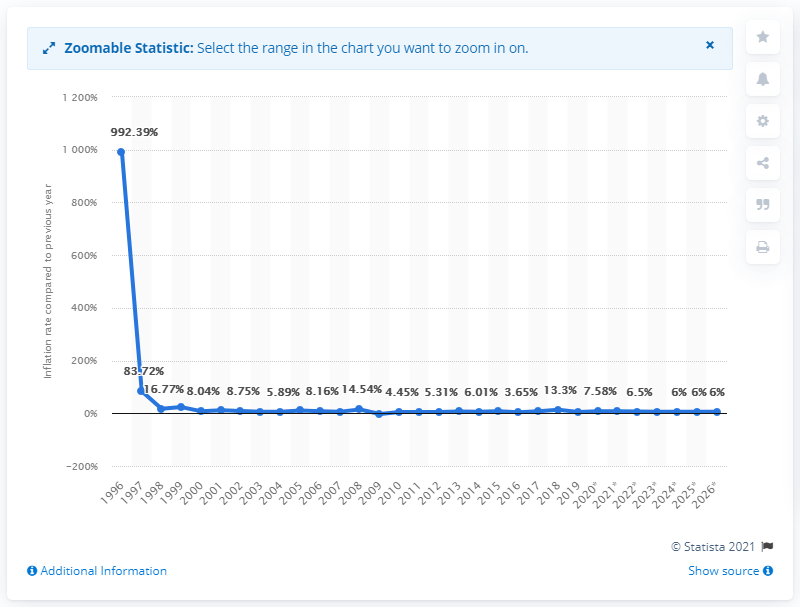Specify some key components in this picture. In 2019, the inflation rate in Turkmenistan was 5.09%. 